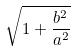<formula> <loc_0><loc_0><loc_500><loc_500>\sqrt { 1 + \frac { b ^ { 2 } } { a ^ { 2 } } }</formula> 